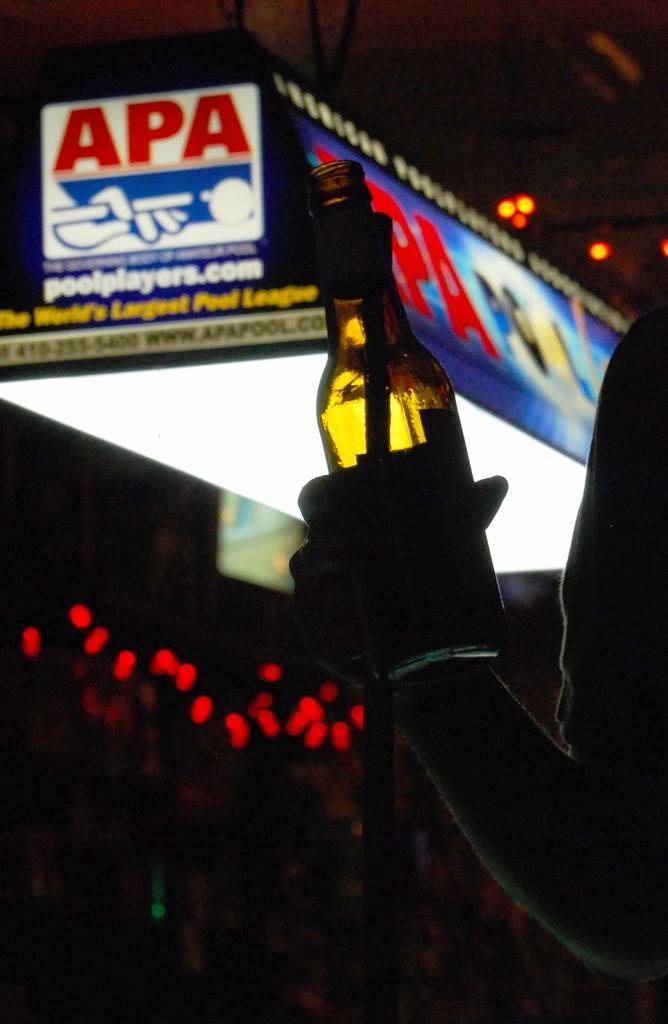<image>
Summarize the visual content of the image. The website advertised is pool players dot com. 